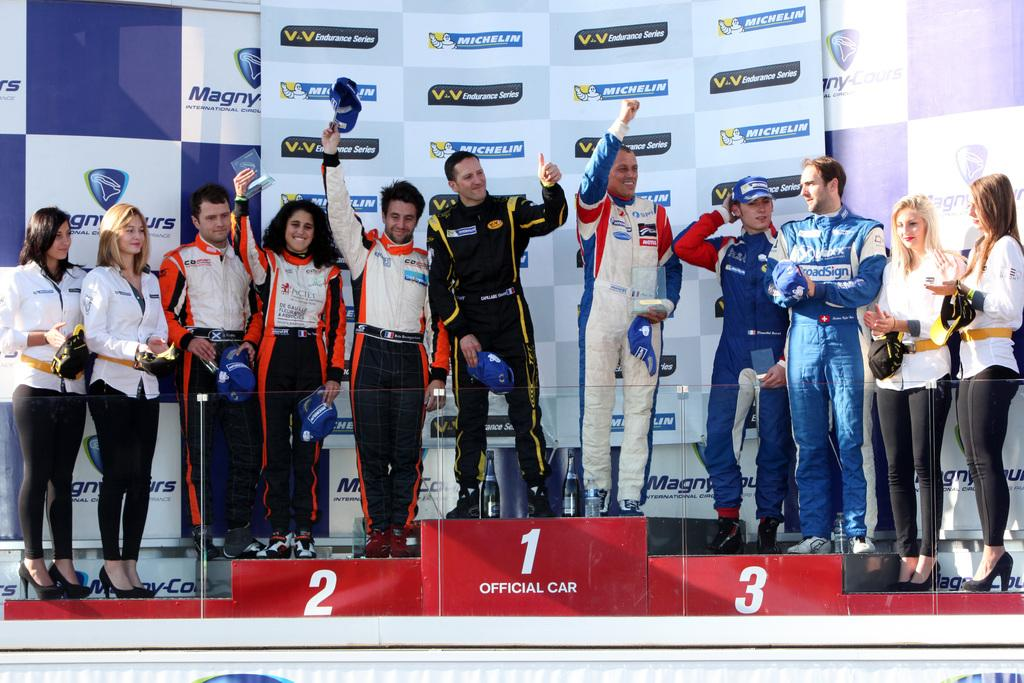What is happening in the image? There are people standing in the image. What are the people holding? The people are holding objects. What can be seen in the background of the image? There are boards with text and images in the background of the image. What type of goat can be seen interacting with the people in the image? There is no goat present in the image; only people holding objects and boards with text and images are visible. What kind of glue is being used by the people in the image? There is no indication of any glue being used in the image; the people are simply holding objects. 